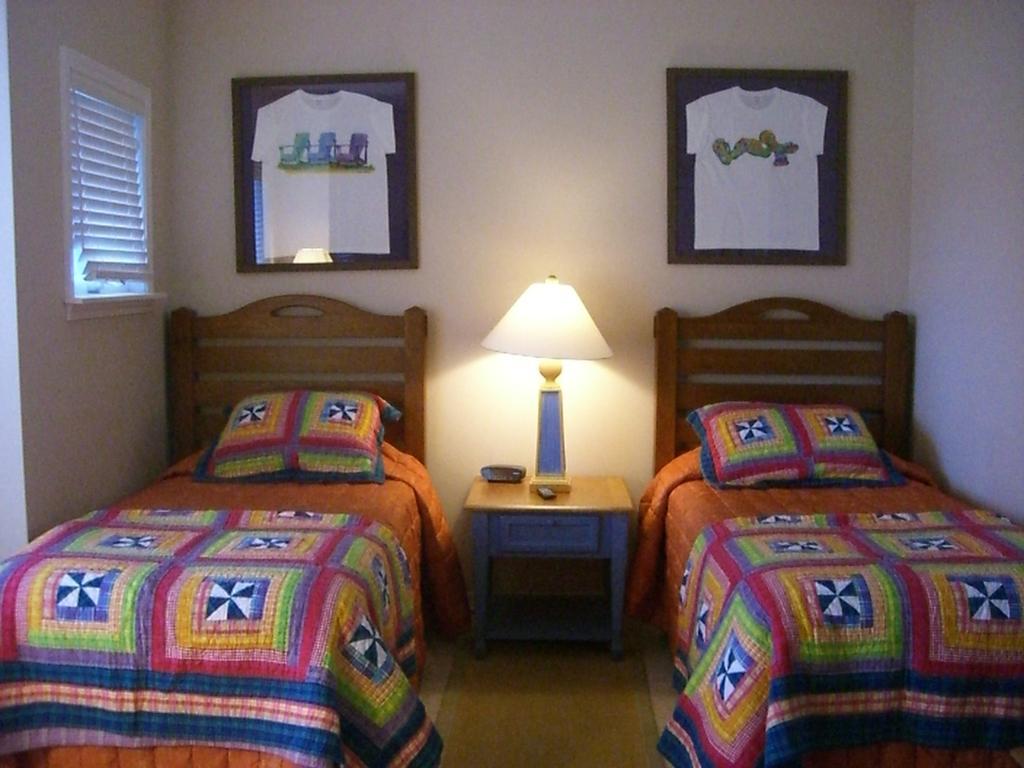Describe this image in one or two sentences. In the image I can see two beds on which there are blankets, pillows and a table on which there is a lamp and also I can see two frames to the wall and a window to the side. 